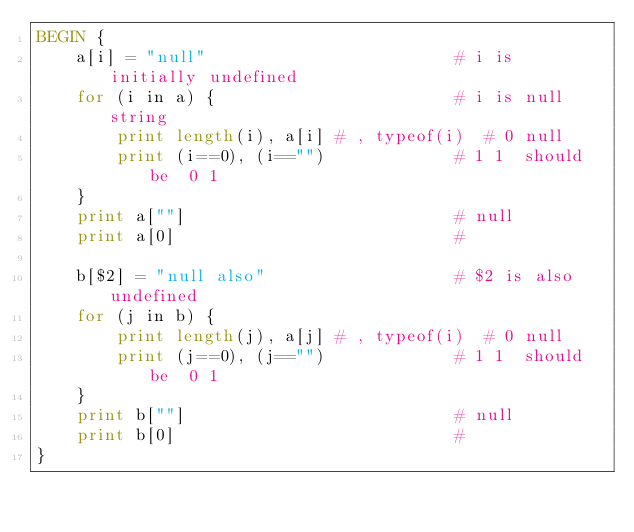<code> <loc_0><loc_0><loc_500><loc_500><_Awk_>BEGIN {
    a[i] = "null"                         # i is initially undefined
    for (i in a) {                        # i is null string
        print length(i), a[i] # , typeof(i)  # 0 null
        print (i==0), (i=="")             # 1 1  should be  0 1
    }
    print a[""]                           # null
    print a[0]                            #

    b[$2] = "null also"                   # $2 is also undefined
    for (j in b) {
        print length(j), a[j] # , typeof(i)  # 0 null
        print (j==0), (j=="")             # 1 1  should be  0 1
    }
    print b[""]                           # null
    print b[0]                            #
}
</code> 